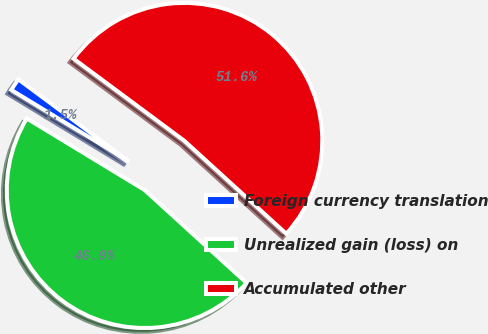Convert chart to OTSL. <chart><loc_0><loc_0><loc_500><loc_500><pie_chart><fcel>Foreign currency translation<fcel>Unrealized gain (loss) on<fcel>Accumulated other<nl><fcel>1.47%<fcel>46.92%<fcel>51.61%<nl></chart> 